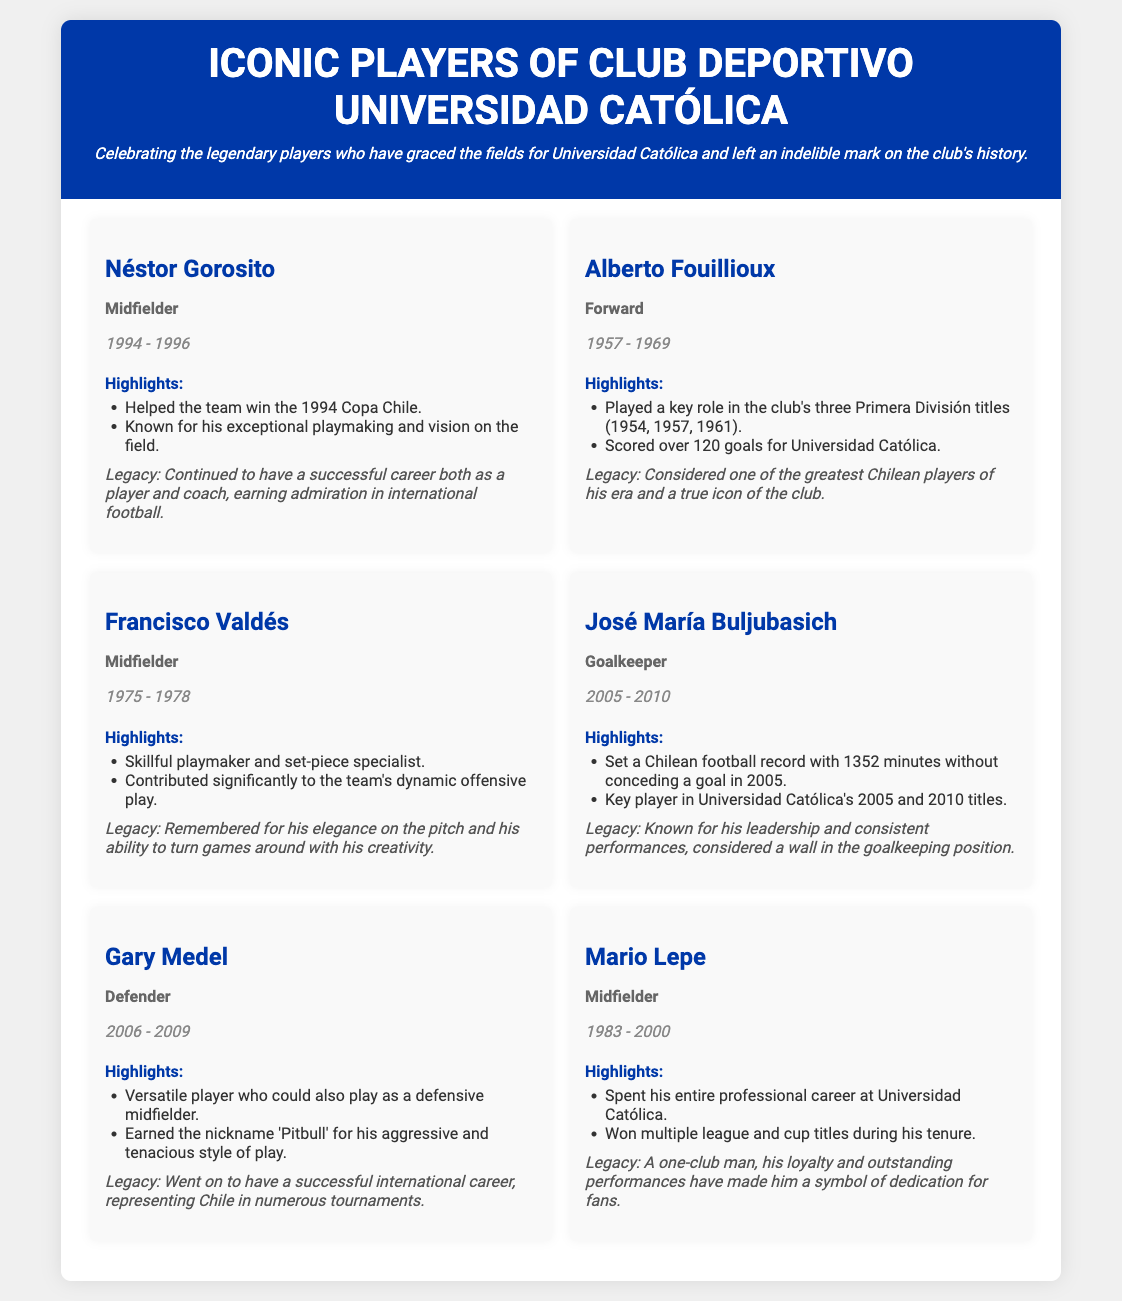what position did Néstor Gorosito play? Néstor Gorosito is listed as a Midfielder in the document.
Answer: Midfielder which title did Alberto Fouillioux help win during his time at the club? The document states that he helped the team win the 1994 Copa Chile.
Answer: 1994 Copa Chile how many goals did Alberto Fouillioux score for Universidad Católica? The document indicates he scored over 120 goals for the club.
Answer: over 120 goals what is the main legacy of Gary Medel according to the document? The document mentions that he went on to have a successful international career, representing Chile in numerous tournaments.
Answer: successful international career which player set a record of 1352 minutes without conceding a goal? The document gives the name José María Buljubasich as the player who set this record.
Answer: José María Buljubasich who is considered a symbol of dedication for the fans due to loyalty? The document highlights Mario Lepe as a one-club man, making him a symbol of dedication.
Answer: Mario Lepe what years did Francisco Valdés play for Universidad Católica? According to the document, Francisco Valdés played from 1975 to 1978.
Answer: 1975 - 1978 how long did Néstor Gorosito play for Universidad Católica? The document states he played from 1994 to 1996, which is a duration of 2 years.
Answer: 2 years which player has the nickname 'Pitbull'? The document states that Gary Medel earned the nickname 'Pitbull' for his aggressive style of play.
Answer: Gary Medel 